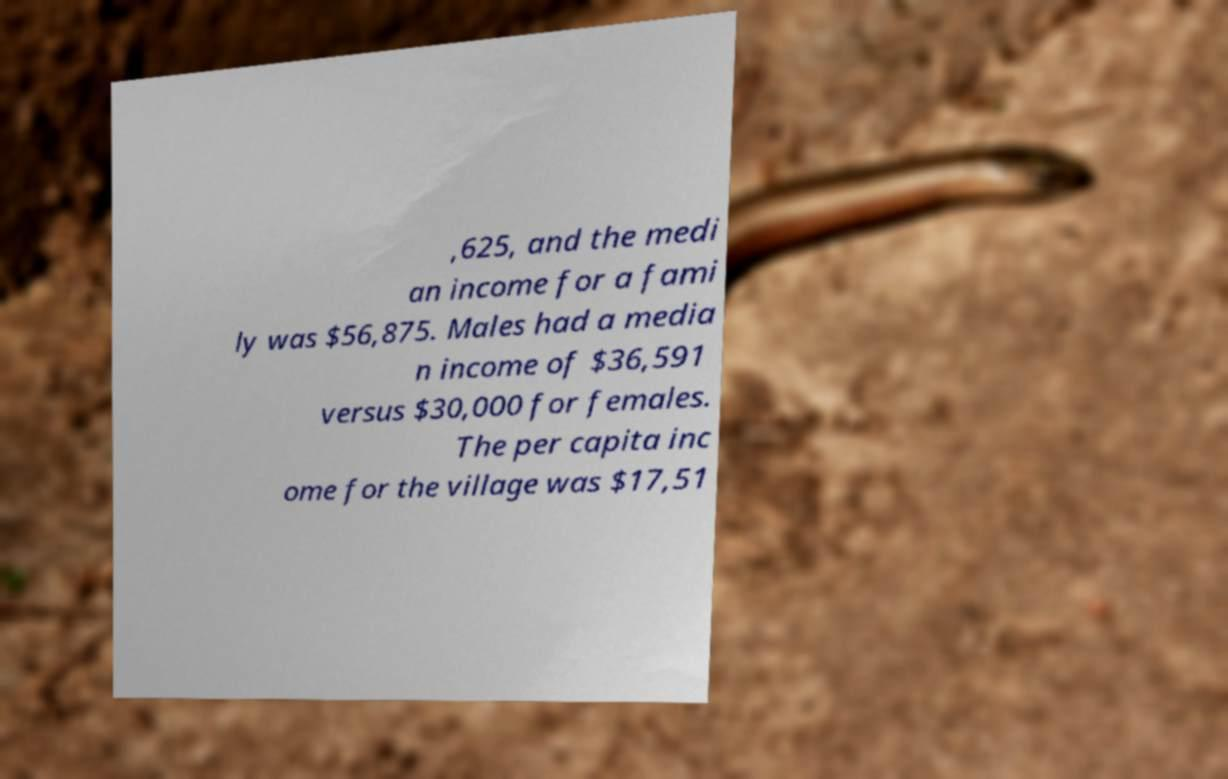There's text embedded in this image that I need extracted. Can you transcribe it verbatim? ,625, and the medi an income for a fami ly was $56,875. Males had a media n income of $36,591 versus $30,000 for females. The per capita inc ome for the village was $17,51 